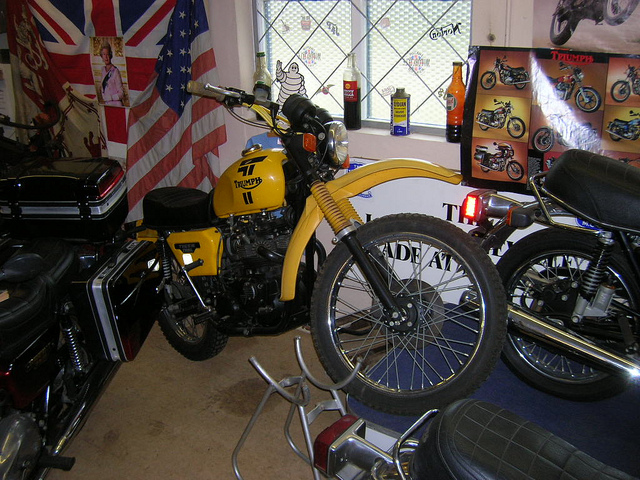Please extract the text content from this image. Triumph THE ADE 